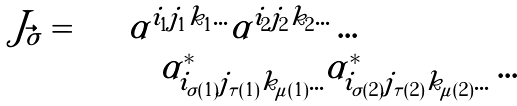<formula> <loc_0><loc_0><loc_500><loc_500>\begin{array} { l l } J _ { \vec { \sigma } } = \sum & \alpha ^ { i _ { 1 } j _ { 1 } k _ { 1 } \dots } \alpha ^ { i _ { 2 } j _ { 2 } k _ { 2 } \dots } \dots \\ & \quad \alpha ^ { * } _ { i _ { \sigma ( 1 ) } j _ { \tau ( 1 ) } k _ { \mu ( 1 ) } \dots } \alpha ^ { * } _ { i _ { \sigma ( 2 ) } j _ { \tau ( 2 ) } k _ { \mu ( 2 ) } \dots } \dots \end{array}</formula> 